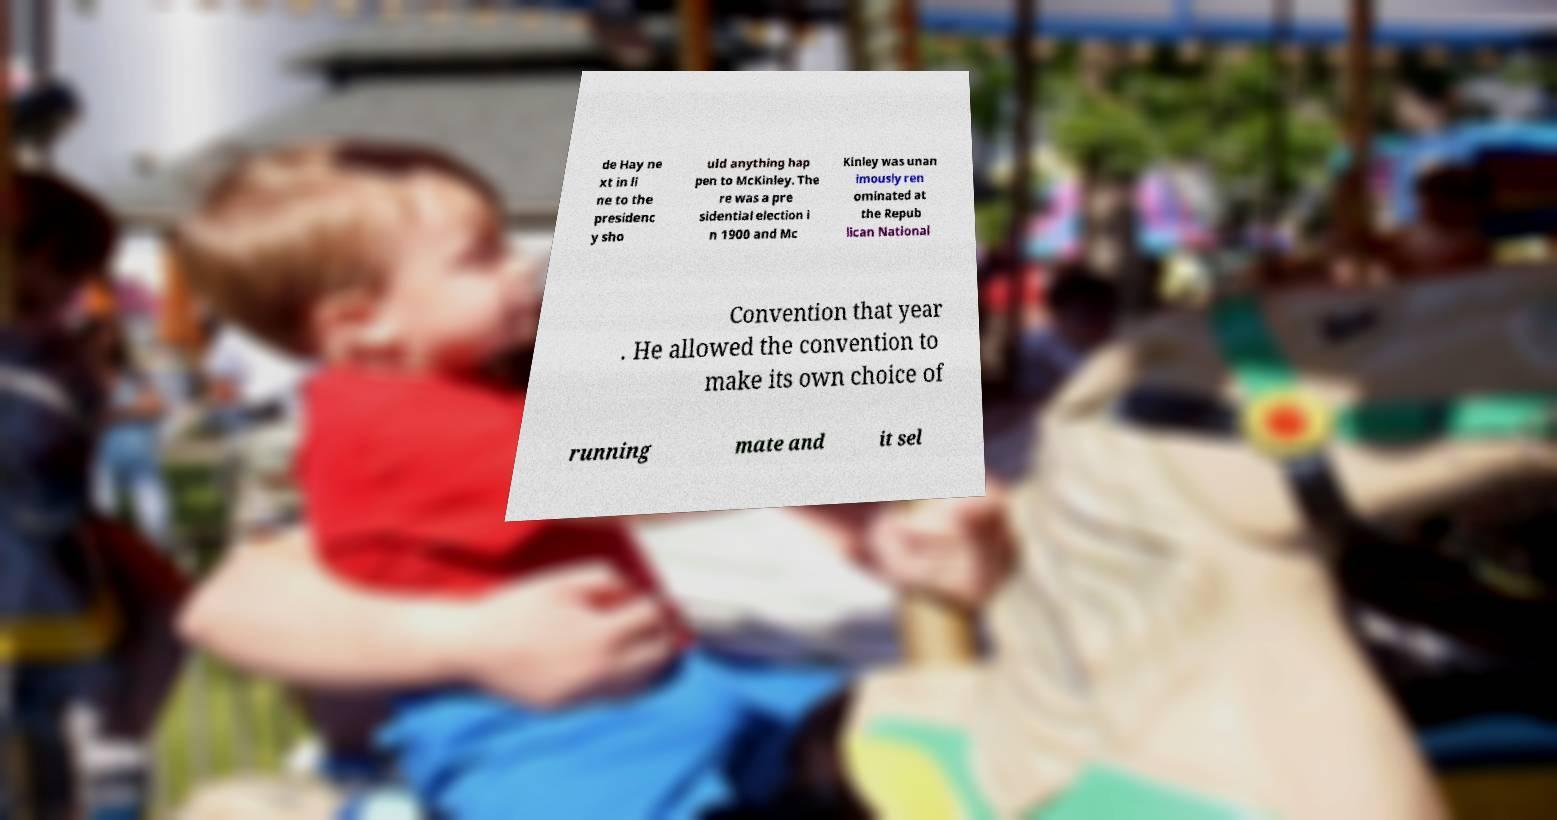Could you assist in decoding the text presented in this image and type it out clearly? de Hay ne xt in li ne to the presidenc y sho uld anything hap pen to McKinley. The re was a pre sidential election i n 1900 and Mc Kinley was unan imously ren ominated at the Repub lican National Convention that year . He allowed the convention to make its own choice of running mate and it sel 